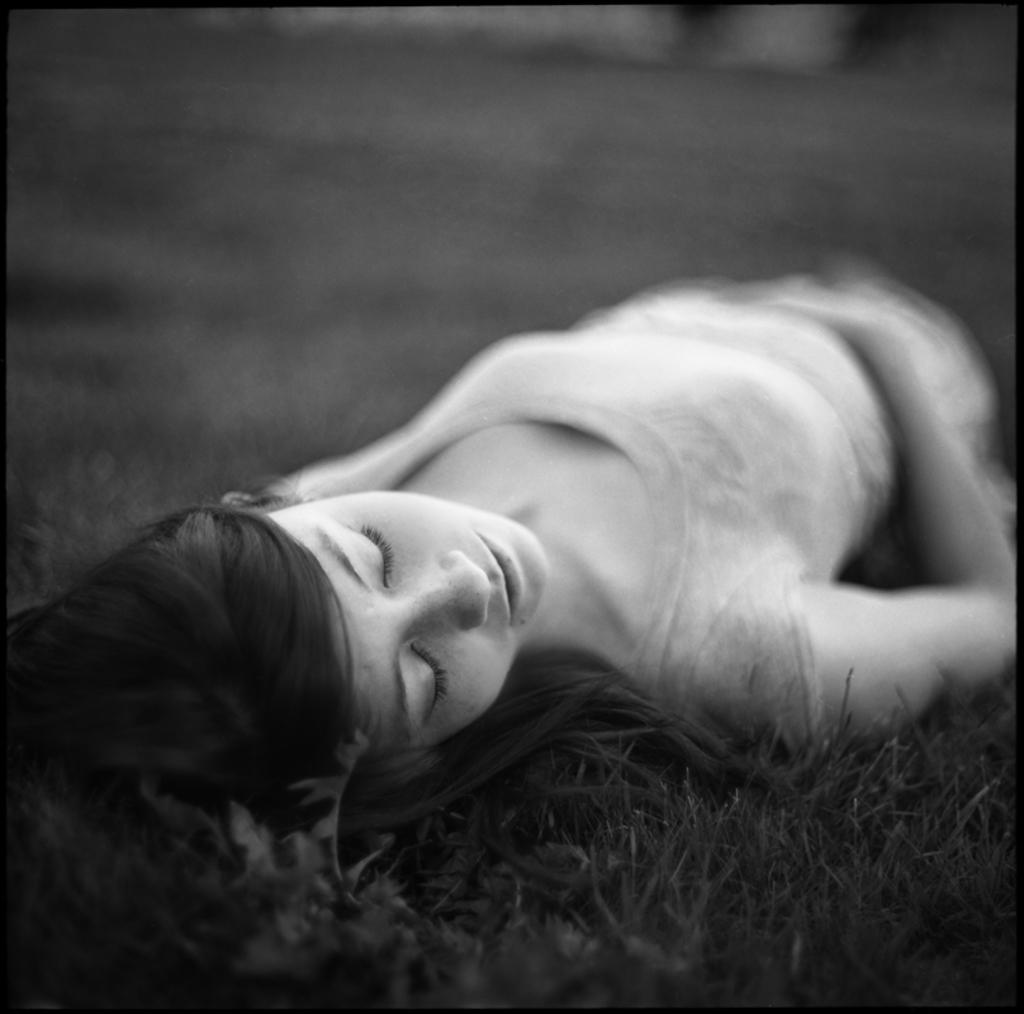Who is the main subject in the image? There is a woman in the image. What is the woman doing in the image? The woman is sleeping on the grass. Can you describe the background of the image? The background of the image is blurred. What color scheme is used in the image? The image is in black and white. What color are the borders of the image? The borders of the image are black. What book is the woman reading in the image? There is no book present in the image, as the woman is sleeping on the grass. 